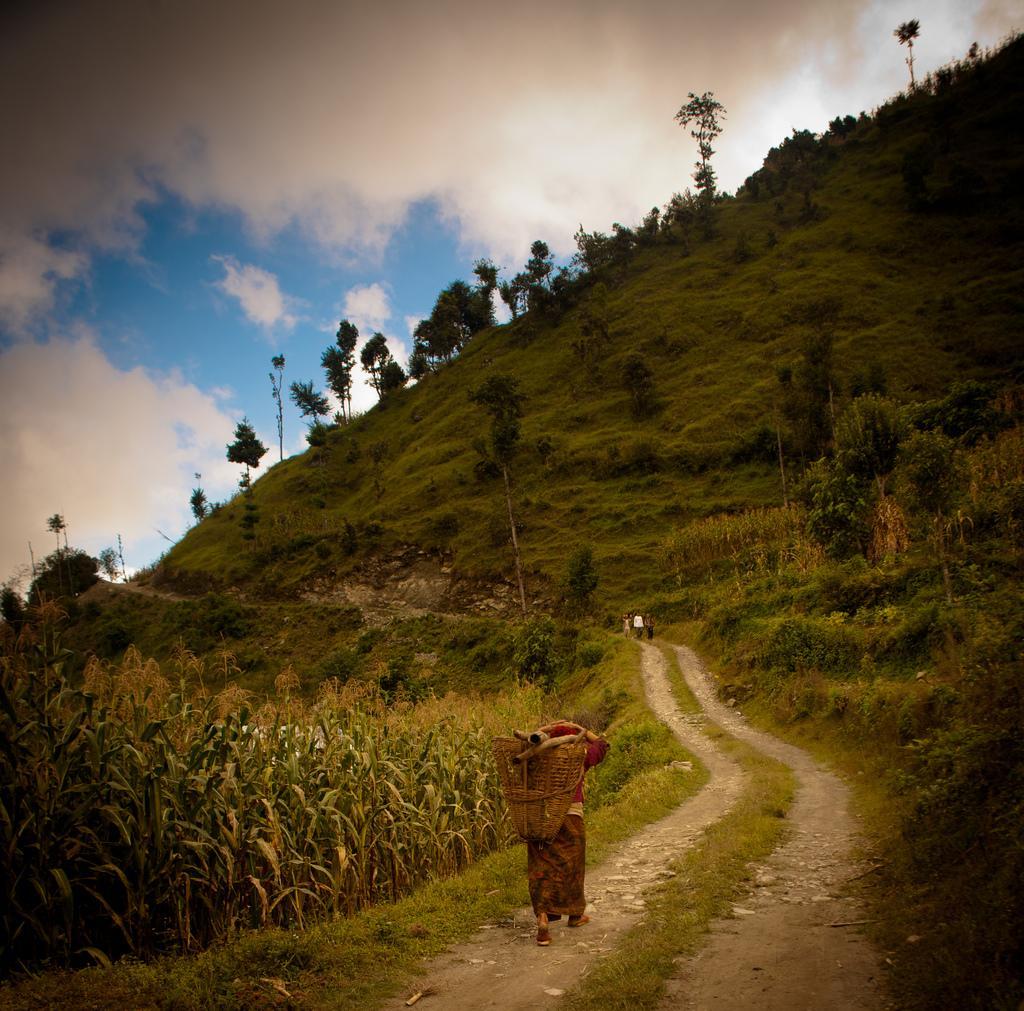Describe this image in one or two sentences. In the center of the image we can see trees, hills, some plants, ground are there. At the bottom of the image we can see a person is walking and holding an object. In the middle of the image some persons are there. At the top of the image clouds are present in the sky. 